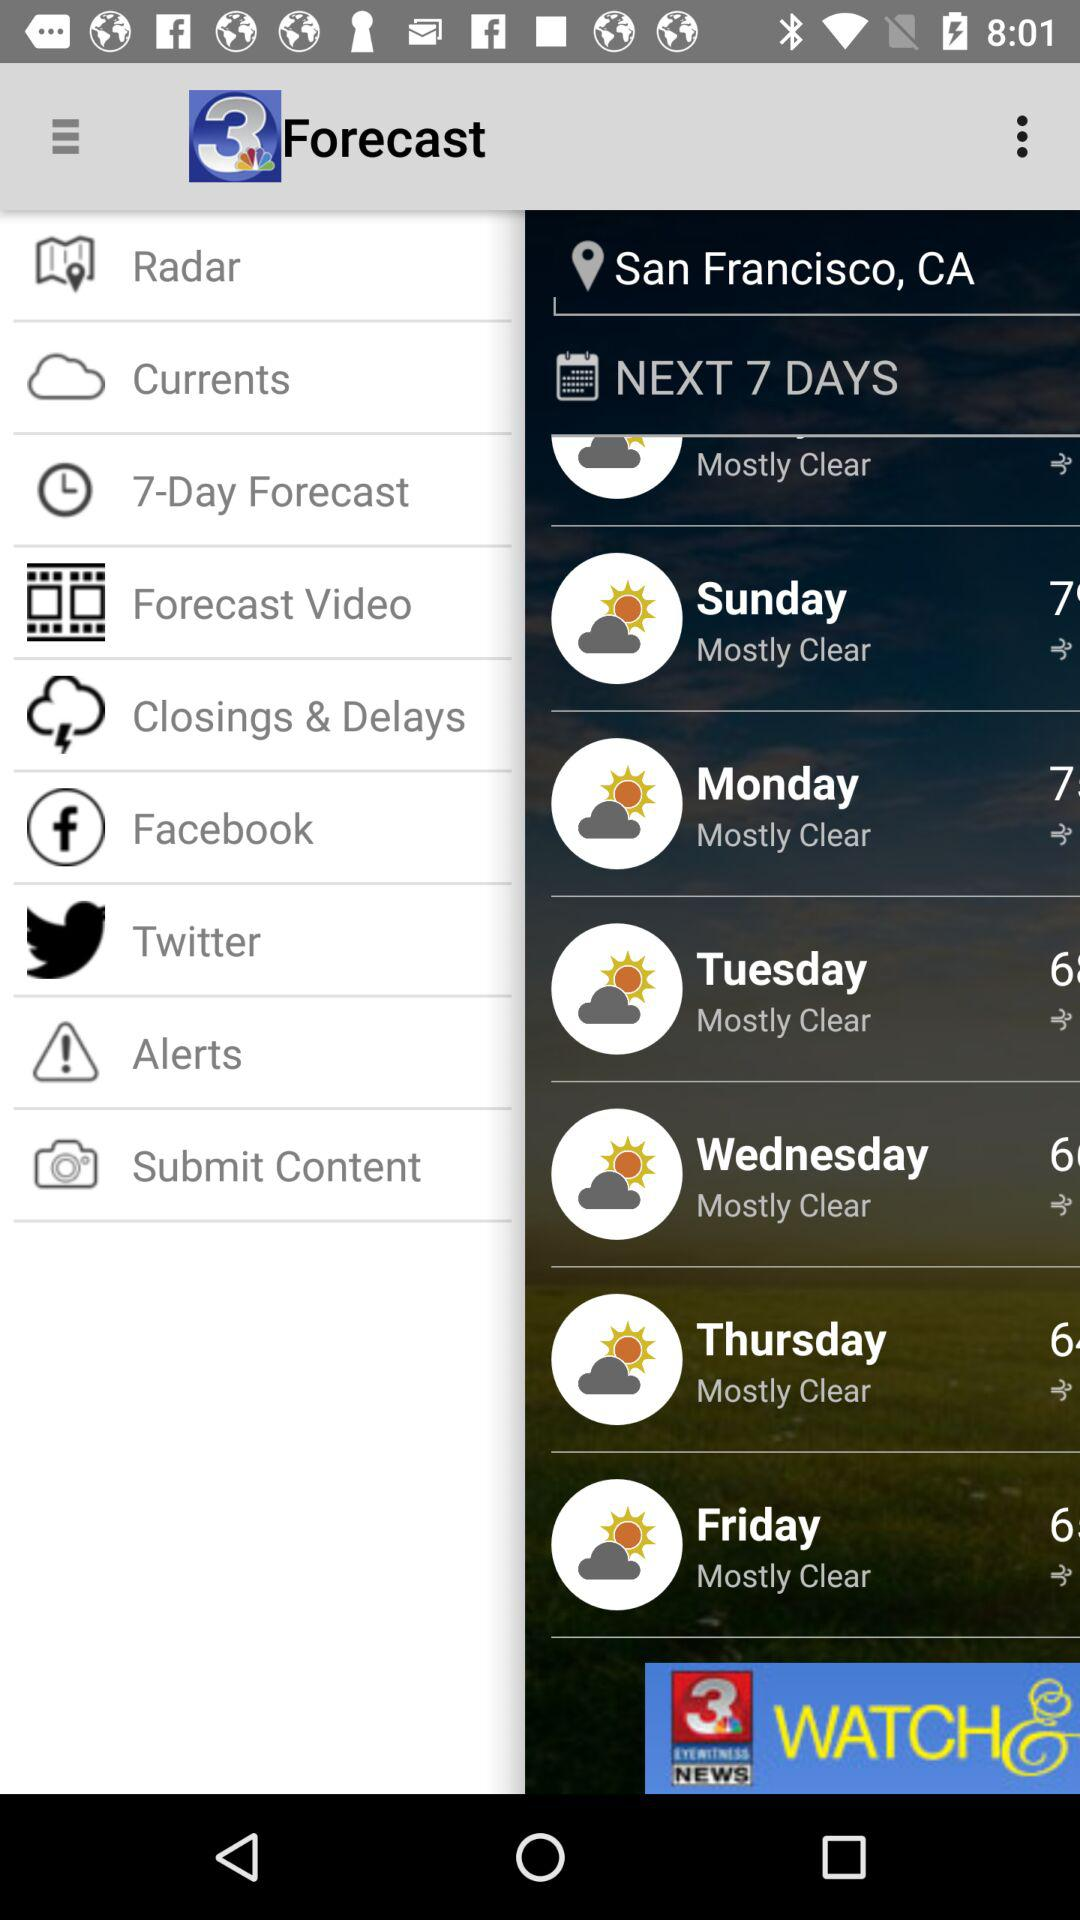Which location is selected for the forecast? The location that is selected for the forecast is San Francisco, CA. 